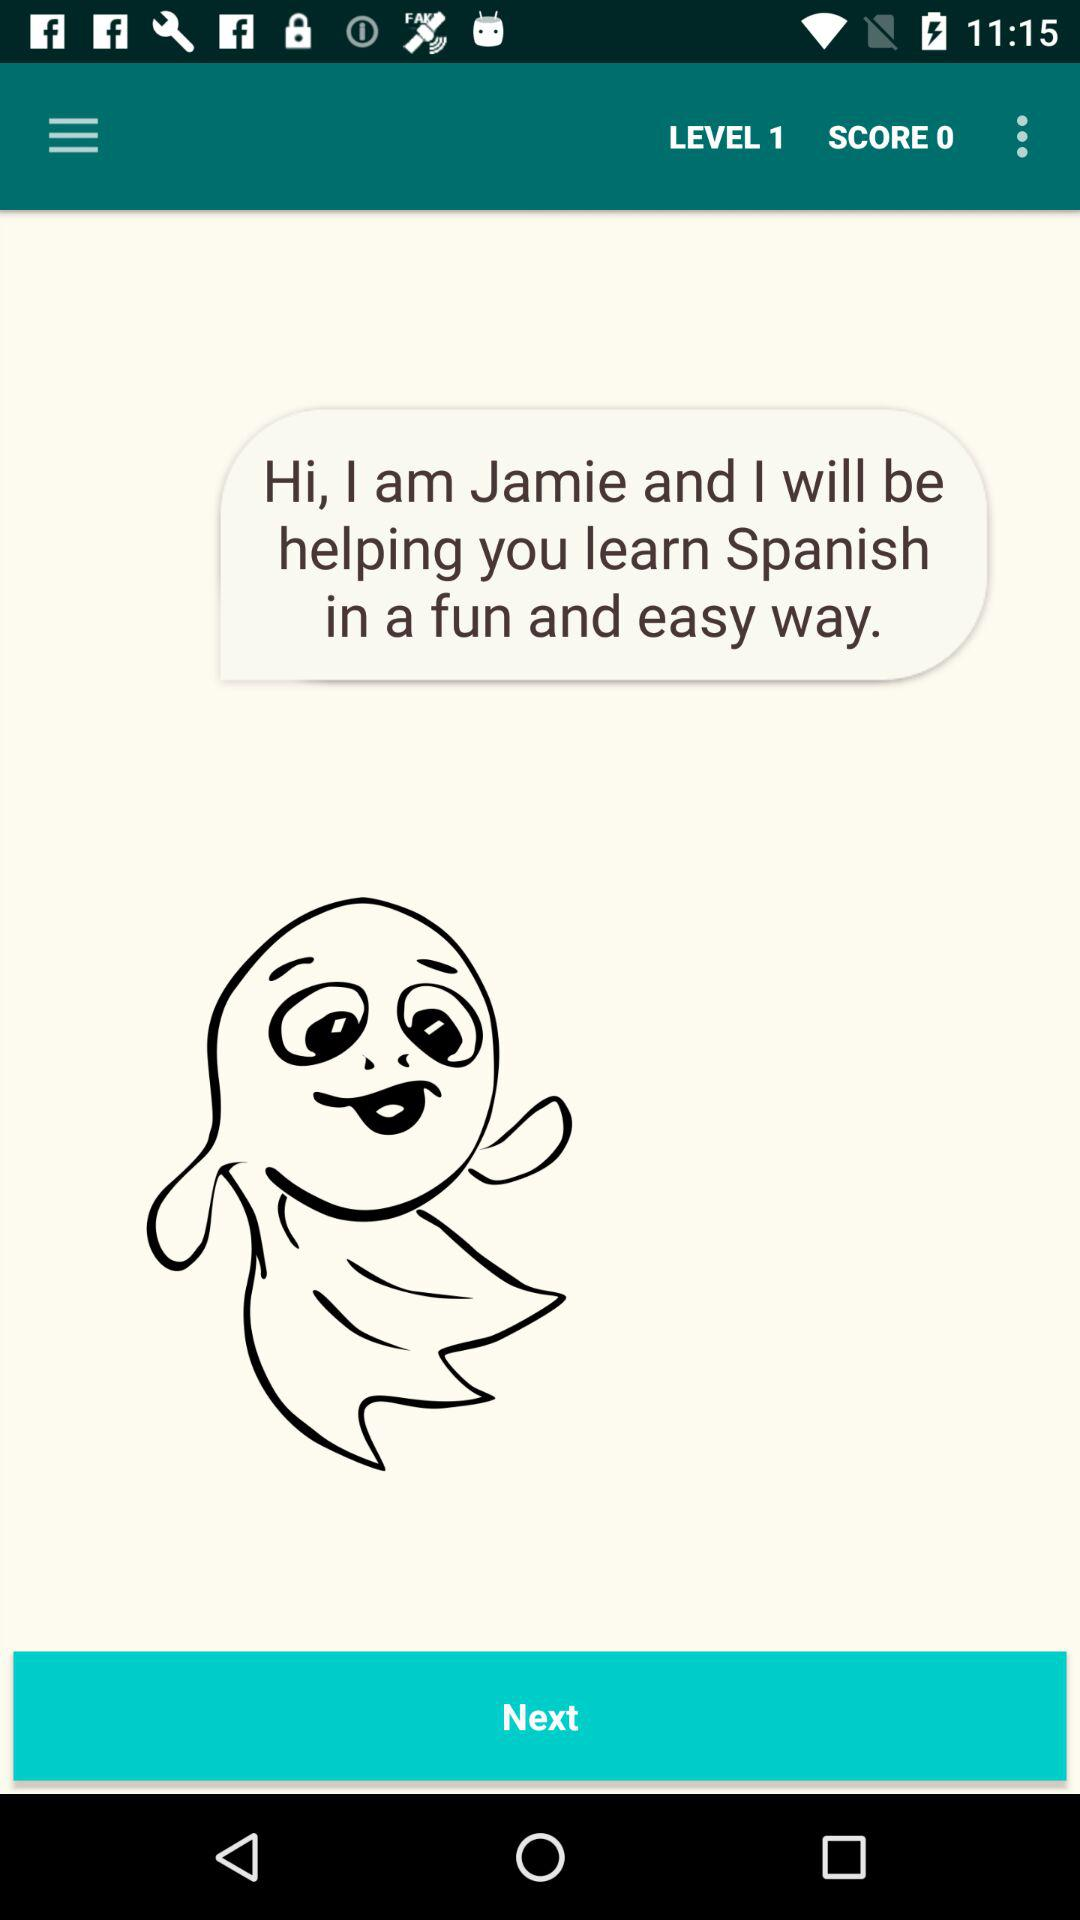What is the score displayed on the screen? The displayed score on the screen is 0. 